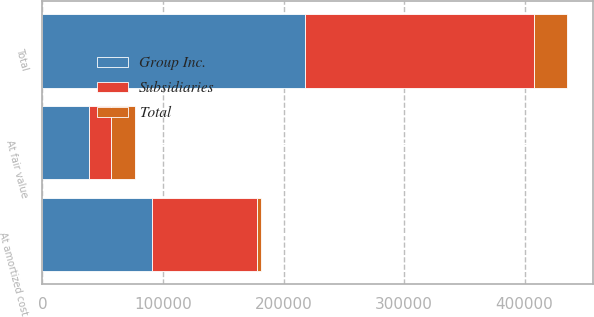Convert chart to OTSL. <chart><loc_0><loc_0><loc_500><loc_500><stacked_bar_chart><ecel><fcel>At amortized cost<fcel>At fair value<fcel>Total<nl><fcel>Subsidiaries<fcel>86951<fcel>18207<fcel>190482<nl><fcel>Total<fcel>3852<fcel>20284<fcel>27205<nl><fcel>Group Inc.<fcel>90803<fcel>38491<fcel>217687<nl></chart> 